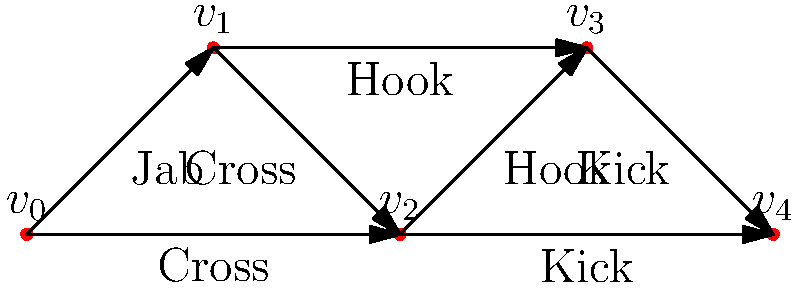In the directed graph above, each vertex represents a position in a kickboxing combo, and each edge represents a possible move. What is the maximum number of unique moves that can be executed in a single combo starting from $v_0$ and ending at $v_4$? To find the maximum number of unique moves in a combo from $v_0$ to $v_4$, we need to count all possible paths from $v_0$ to $v_4$. Let's break it down step-by-step:

1. There are three possible paths from $v_0$ to $v_4$:
   a) $v_0 \rightarrow v_1 \rightarrow v_2 \rightarrow v_3 \rightarrow v_4$
   b) $v_0 \rightarrow v_1 \rightarrow v_3 \rightarrow v_4$
   c) $v_0 \rightarrow v_2 \rightarrow v_4$

2. Let's count the unique moves in each path:
   a) Jab, Cross, Hook, Kick (4 moves)
   b) Jab, Hook, Kick (3 moves)
   c) Cross, Kick (2 moves)

3. The path with the maximum number of unique moves is path (a), which contains 4 moves.

Therefore, the maximum number of unique moves that can be executed in a single combo starting from $v_0$ and ending at $v_4$ is 4.
Answer: 4 